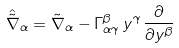Convert formula to latex. <formula><loc_0><loc_0><loc_500><loc_500>\hat { \tilde { \nabla } } _ { \alpha } = \tilde { \nabla } _ { \alpha } - \Gamma _ { \alpha \gamma } ^ { \beta } \, y ^ { \gamma } \, \frac { \partial } { \partial y ^ { \beta } }</formula> 